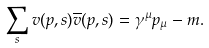<formula> <loc_0><loc_0><loc_500><loc_500>\sum _ { s } v ( p , s ) \overline { v } ( p , s ) = \gamma ^ { \mu } p _ { \mu } - m .</formula> 